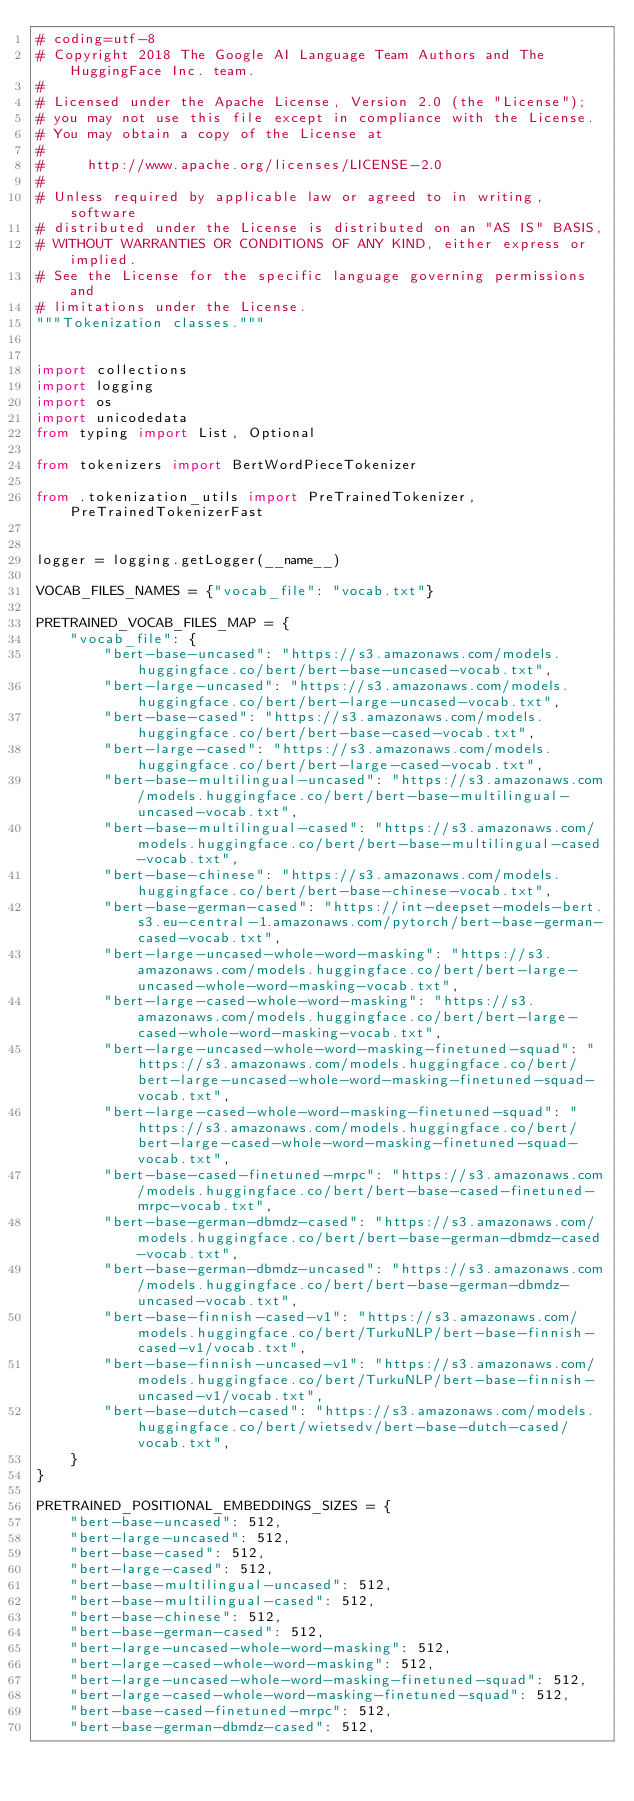<code> <loc_0><loc_0><loc_500><loc_500><_Python_># coding=utf-8
# Copyright 2018 The Google AI Language Team Authors and The HuggingFace Inc. team.
#
# Licensed under the Apache License, Version 2.0 (the "License");
# you may not use this file except in compliance with the License.
# You may obtain a copy of the License at
#
#     http://www.apache.org/licenses/LICENSE-2.0
#
# Unless required by applicable law or agreed to in writing, software
# distributed under the License is distributed on an "AS IS" BASIS,
# WITHOUT WARRANTIES OR CONDITIONS OF ANY KIND, either express or implied.
# See the License for the specific language governing permissions and
# limitations under the License.
"""Tokenization classes."""


import collections
import logging
import os
import unicodedata
from typing import List, Optional

from tokenizers import BertWordPieceTokenizer

from .tokenization_utils import PreTrainedTokenizer, PreTrainedTokenizerFast


logger = logging.getLogger(__name__)

VOCAB_FILES_NAMES = {"vocab_file": "vocab.txt"}

PRETRAINED_VOCAB_FILES_MAP = {
    "vocab_file": {
        "bert-base-uncased": "https://s3.amazonaws.com/models.huggingface.co/bert/bert-base-uncased-vocab.txt",
        "bert-large-uncased": "https://s3.amazonaws.com/models.huggingface.co/bert/bert-large-uncased-vocab.txt",
        "bert-base-cased": "https://s3.amazonaws.com/models.huggingface.co/bert/bert-base-cased-vocab.txt",
        "bert-large-cased": "https://s3.amazonaws.com/models.huggingface.co/bert/bert-large-cased-vocab.txt",
        "bert-base-multilingual-uncased": "https://s3.amazonaws.com/models.huggingface.co/bert/bert-base-multilingual-uncased-vocab.txt",
        "bert-base-multilingual-cased": "https://s3.amazonaws.com/models.huggingface.co/bert/bert-base-multilingual-cased-vocab.txt",
        "bert-base-chinese": "https://s3.amazonaws.com/models.huggingface.co/bert/bert-base-chinese-vocab.txt",
        "bert-base-german-cased": "https://int-deepset-models-bert.s3.eu-central-1.amazonaws.com/pytorch/bert-base-german-cased-vocab.txt",
        "bert-large-uncased-whole-word-masking": "https://s3.amazonaws.com/models.huggingface.co/bert/bert-large-uncased-whole-word-masking-vocab.txt",
        "bert-large-cased-whole-word-masking": "https://s3.amazonaws.com/models.huggingface.co/bert/bert-large-cased-whole-word-masking-vocab.txt",
        "bert-large-uncased-whole-word-masking-finetuned-squad": "https://s3.amazonaws.com/models.huggingface.co/bert/bert-large-uncased-whole-word-masking-finetuned-squad-vocab.txt",
        "bert-large-cased-whole-word-masking-finetuned-squad": "https://s3.amazonaws.com/models.huggingface.co/bert/bert-large-cased-whole-word-masking-finetuned-squad-vocab.txt",
        "bert-base-cased-finetuned-mrpc": "https://s3.amazonaws.com/models.huggingface.co/bert/bert-base-cased-finetuned-mrpc-vocab.txt",
        "bert-base-german-dbmdz-cased": "https://s3.amazonaws.com/models.huggingface.co/bert/bert-base-german-dbmdz-cased-vocab.txt",
        "bert-base-german-dbmdz-uncased": "https://s3.amazonaws.com/models.huggingface.co/bert/bert-base-german-dbmdz-uncased-vocab.txt",
        "bert-base-finnish-cased-v1": "https://s3.amazonaws.com/models.huggingface.co/bert/TurkuNLP/bert-base-finnish-cased-v1/vocab.txt",
        "bert-base-finnish-uncased-v1": "https://s3.amazonaws.com/models.huggingface.co/bert/TurkuNLP/bert-base-finnish-uncased-v1/vocab.txt",
        "bert-base-dutch-cased": "https://s3.amazonaws.com/models.huggingface.co/bert/wietsedv/bert-base-dutch-cased/vocab.txt",
    }
}

PRETRAINED_POSITIONAL_EMBEDDINGS_SIZES = {
    "bert-base-uncased": 512,
    "bert-large-uncased": 512,
    "bert-base-cased": 512,
    "bert-large-cased": 512,
    "bert-base-multilingual-uncased": 512,
    "bert-base-multilingual-cased": 512,
    "bert-base-chinese": 512,
    "bert-base-german-cased": 512,
    "bert-large-uncased-whole-word-masking": 512,
    "bert-large-cased-whole-word-masking": 512,
    "bert-large-uncased-whole-word-masking-finetuned-squad": 512,
    "bert-large-cased-whole-word-masking-finetuned-squad": 512,
    "bert-base-cased-finetuned-mrpc": 512,
    "bert-base-german-dbmdz-cased": 512,</code> 